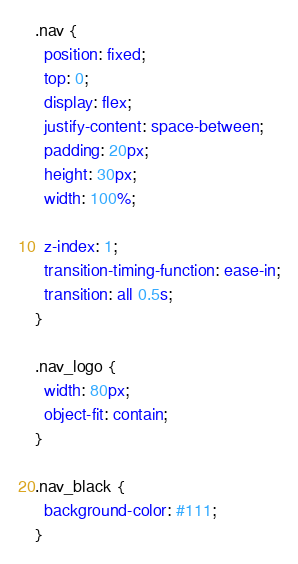Convert code to text. <code><loc_0><loc_0><loc_500><loc_500><_CSS_>.nav {
  position: fixed;
  top: 0;
  display: flex;
  justify-content: space-between;
  padding: 20px;
  height: 30px;
  width: 100%;

  z-index: 1;
  transition-timing-function: ease-in;
  transition: all 0.5s;
}

.nav_logo {
  width: 80px;
  object-fit: contain;
}

.nav_black {
  background-color: #111;
}
</code> 